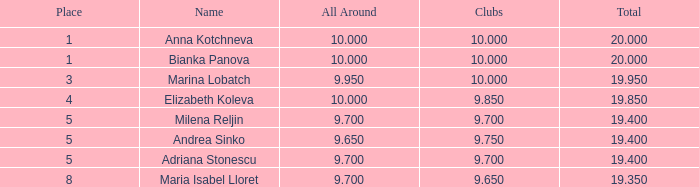How many places have bianka panova as the name, with clubs less than 10? 0.0. 